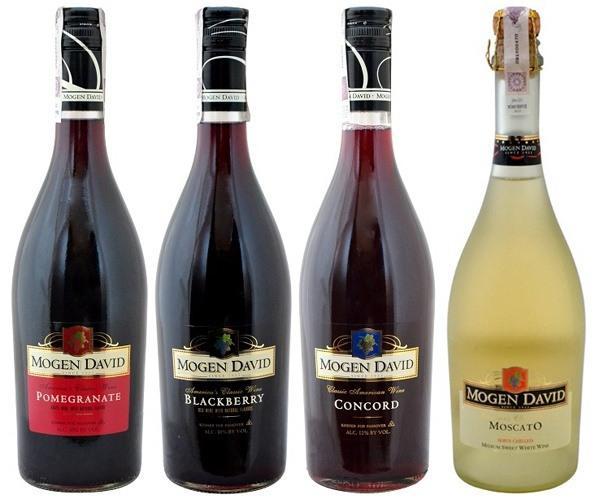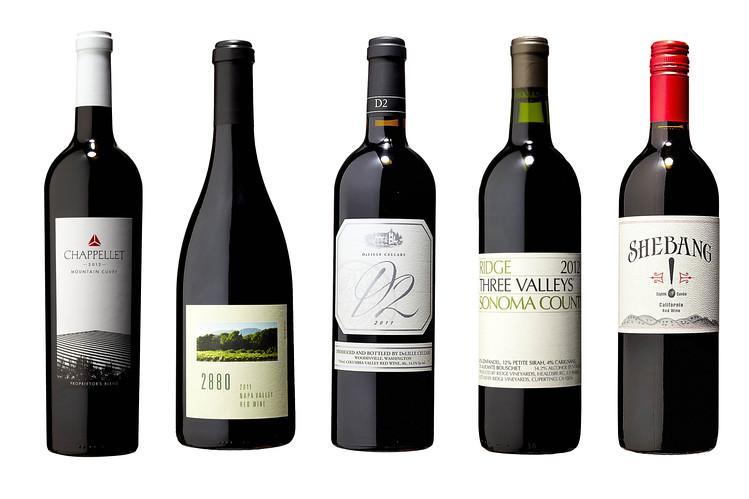The first image is the image on the left, the second image is the image on the right. Given the left and right images, does the statement "One image shows exactly three bottles, all with the same shape and same bottle color." hold true? Answer yes or no. No. The first image is the image on the left, the second image is the image on the right. Analyze the images presented: Is the assertion "The right image contains exactly three wine bottles in a horizontal row." valid? Answer yes or no. No. 